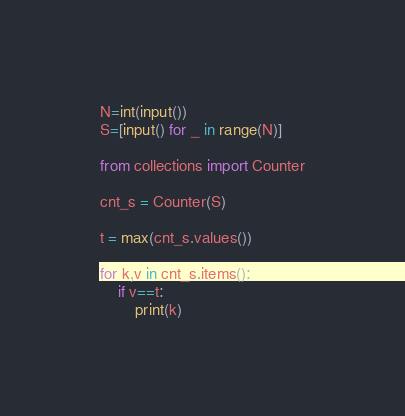Convert code to text. <code><loc_0><loc_0><loc_500><loc_500><_Python_>N=int(input())
S=[input() for _ in range(N)]

from collections import Counter

cnt_s = Counter(S)

t = max(cnt_s.values())

for k,v in cnt_s.items():
    if v==t:
        print(k)</code> 